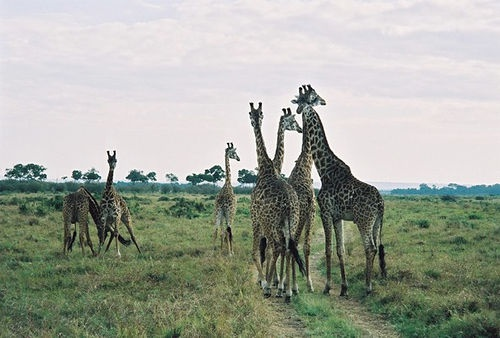Describe the objects in this image and their specific colors. I can see giraffe in lavender, black, gray, and darkgray tones, giraffe in lavender, gray, black, darkgreen, and darkgray tones, giraffe in lavender, gray, black, darkgreen, and darkgray tones, giraffe in lavender, black, gray, and darkgreen tones, and giraffe in lavender, black, gray, and darkgray tones in this image. 